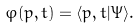<formula> <loc_0><loc_0><loc_500><loc_500>\varphi ( p , t ) = \langle p , t | \Psi \rangle .</formula> 